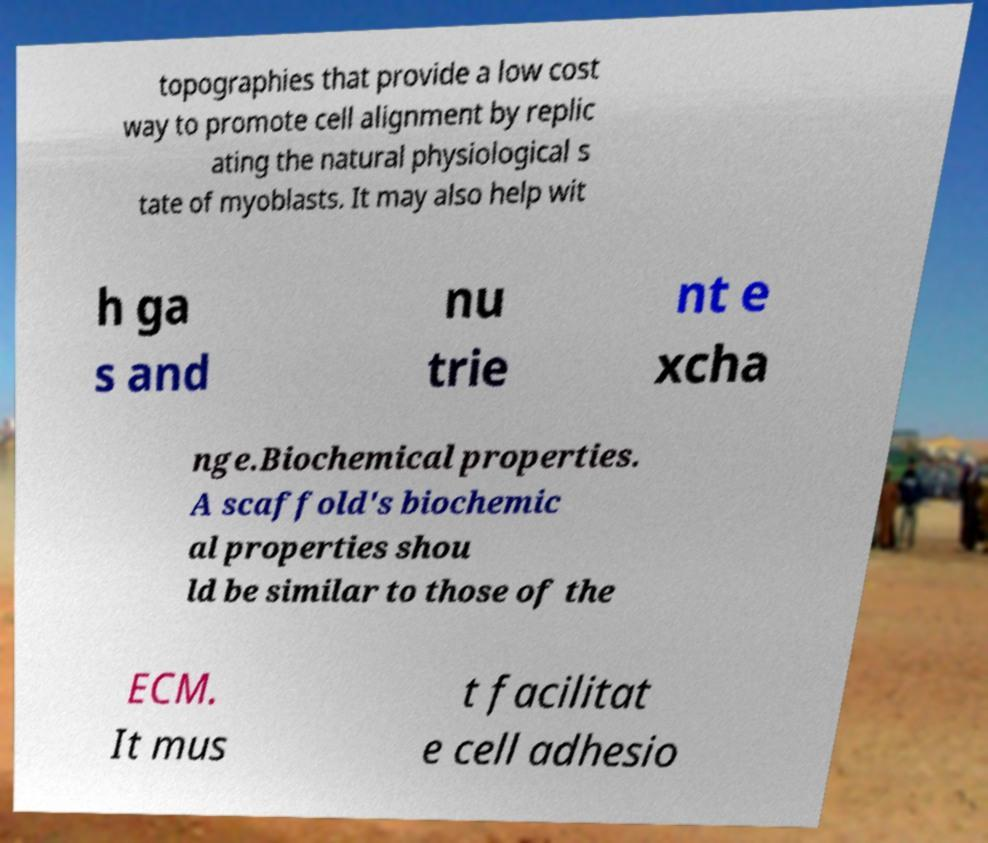Can you accurately transcribe the text from the provided image for me? topographies that provide a low cost way to promote cell alignment by replic ating the natural physiological s tate of myoblasts. It may also help wit h ga s and nu trie nt e xcha nge.Biochemical properties. A scaffold's biochemic al properties shou ld be similar to those of the ECM. It mus t facilitat e cell adhesio 